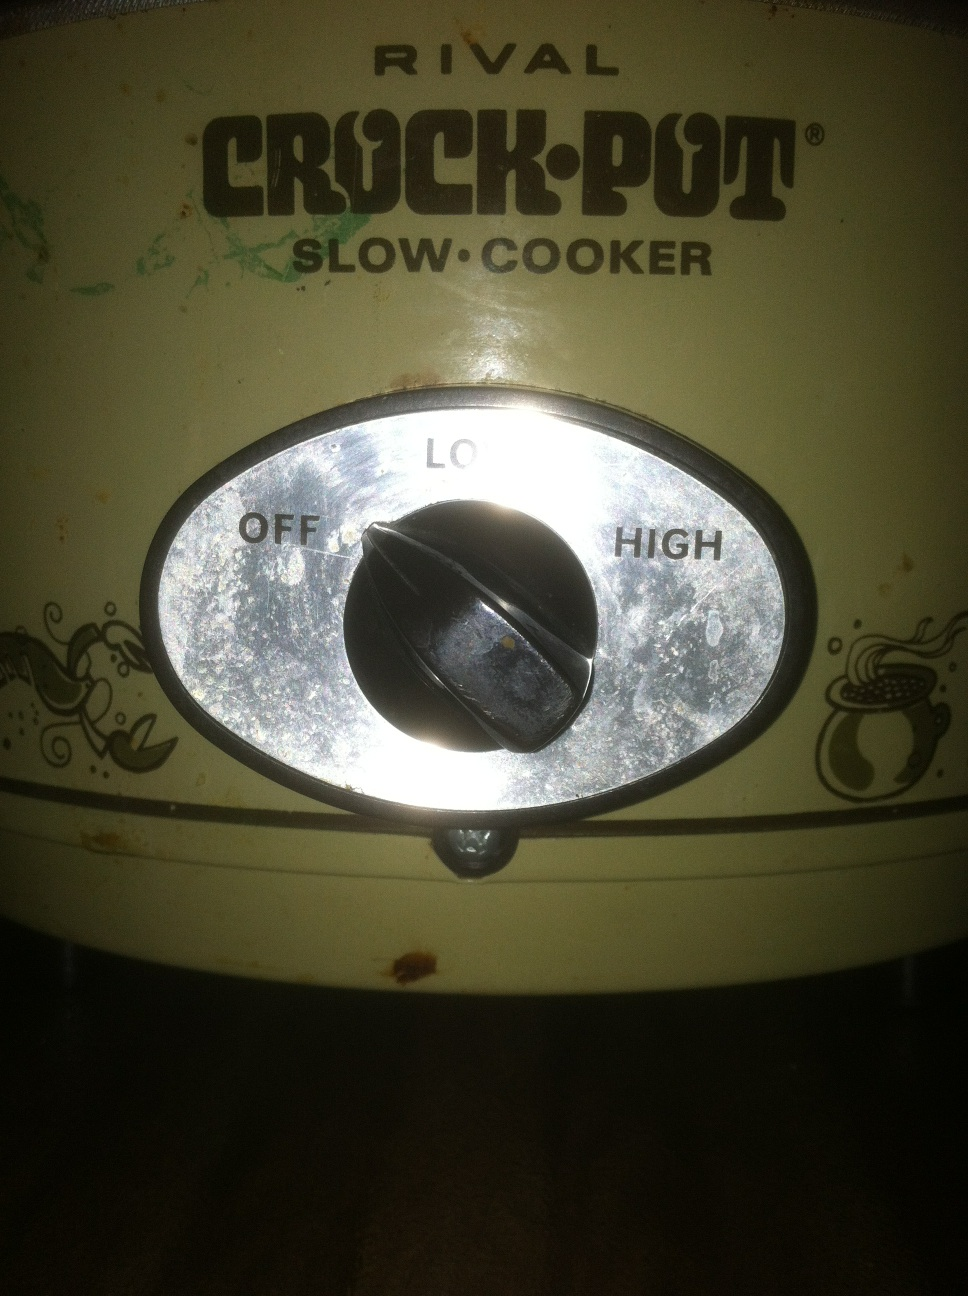What historical significance does this crock pot model have? The Rival Crock-Pot is a significant household appliance, first introduced in the early 1970s. It revolutionized the way people cooked by providing a convenient method to prepare meals with minimal supervision. Its popularity spiked as it catered to the needs of busy families and working individuals, allowing them to come home to a hot, ready-to-eat meal. What advantages does a crock pot offer compared to other cooking methods? Crock pots offer several advantages over traditional cooking methods: they save time and energy by cooking meals slowly over hours, which can be convenient for busy lifestyles. They are great for tenderizing cheaper cuts of meat, making them more flavorful and succulent. Additionally, they help retain nutrients in food due to the low-temperature cooking process. Imagine someone time-travels from the future and stumbles upon this crock pot. What would they think? In a whimsical scenario, a time traveler from a highly advanced future where meals are instantaneously created might regard this crock pot as a charming relic of the past. They might be fascinated by the slow cooking method and the need for patience and preparation. To them, it could symbolize a time when cooking was an art that required time, attention, and care, and they might even admire the simplicity and nostalgia of this culinary artifact. 